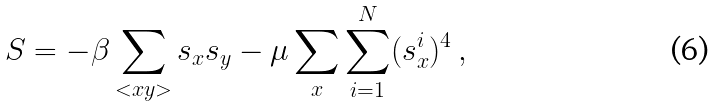Convert formula to latex. <formula><loc_0><loc_0><loc_500><loc_500>S = - \beta \sum _ { < x y > } s _ { x } s _ { y } - \mu \sum _ { x } \sum _ { i = 1 } ^ { N } ( s _ { x } ^ { i } ) ^ { 4 } \, ,</formula> 